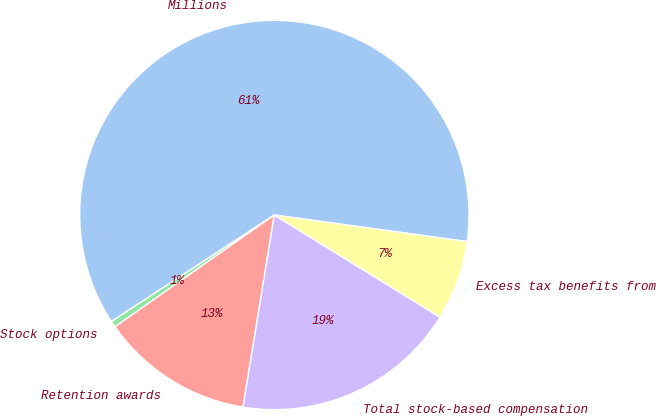Convert chart. <chart><loc_0><loc_0><loc_500><loc_500><pie_chart><fcel>Millions<fcel>Stock options<fcel>Retention awards<fcel>Total stock-based compensation<fcel>Excess tax benefits from<nl><fcel>61.4%<fcel>0.52%<fcel>12.69%<fcel>18.78%<fcel>6.61%<nl></chart> 